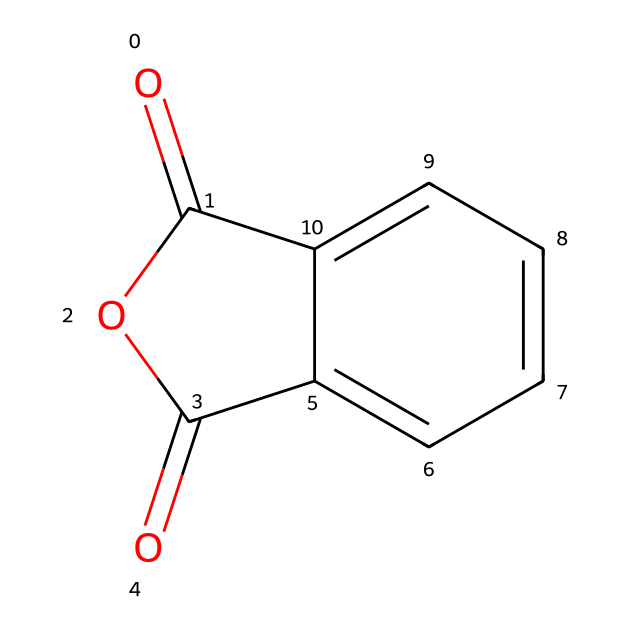What is the main functional group present in phthalic anhydride? The structure of phthalic anhydride includes a cyclic anhydride functional group, which is characteristic of anhydrides. It can be identified by observing the two carbonyl groups adjacent to an oxygen atom in a cyclic arrangement.
Answer: anhydride How many carbon atoms are in phthalic anhydride? By counting the carbon atoms in the SMILES representation, we find there are eight carbon atoms total: three from the benzene ring and two from the anhydride. Thus, there are 6 + 2 = 8 carbon atoms.
Answer: 8 How many oxygen atoms are present in phthalic anhydride? In the SMILES structure, there are three oxygen atoms identified: two in the carbonyl groups at the ends and one as part of the anhydride arrangement, confirming the count.
Answer: 3 Is phthalic anhydride a solid or liquid at room temperature? Phthalic anhydride is known to be a solid at room temperature, as it has a melting point above normal room temperature.
Answer: solid What is a common use of phthalic anhydride in food packaging? Phthalic anhydride is commonly used in the production of certain plasticizers and resins, which help improve flexibility and durability in food packaging materials.
Answer: plasticizers What type of reaction can phthalic anhydride undergo with alcohols? Phthalic anhydride undergoes esterification reactions with alcohols, resulting in the formation of phthalate esters. This is a specific reaction typical of anhydrides when interacting with alcohols.
Answer: esterification What role does phthalic anhydride play in polymer production? Phthalic anhydride acts as a monomer in the synthesis of polyesters, contributing to the formation and stability of the polymer structure.
Answer: monomer 